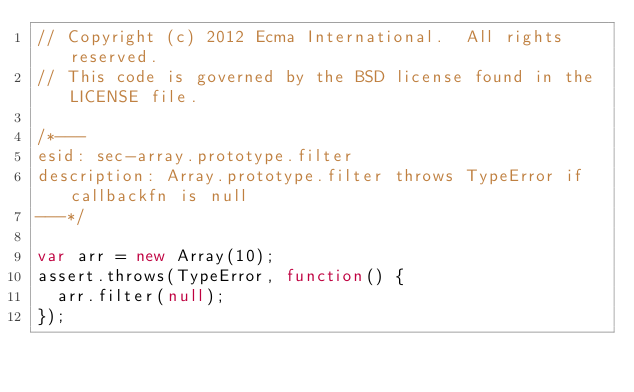<code> <loc_0><loc_0><loc_500><loc_500><_JavaScript_>// Copyright (c) 2012 Ecma International.  All rights reserved.
// This code is governed by the BSD license found in the LICENSE file.

/*---
esid: sec-array.prototype.filter
description: Array.prototype.filter throws TypeError if callbackfn is null
---*/

var arr = new Array(10);
assert.throws(TypeError, function() {
  arr.filter(null);
});
</code> 